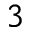Convert formula to latex. <formula><loc_0><loc_0><loc_500><loc_500>_ { 3 }</formula> 